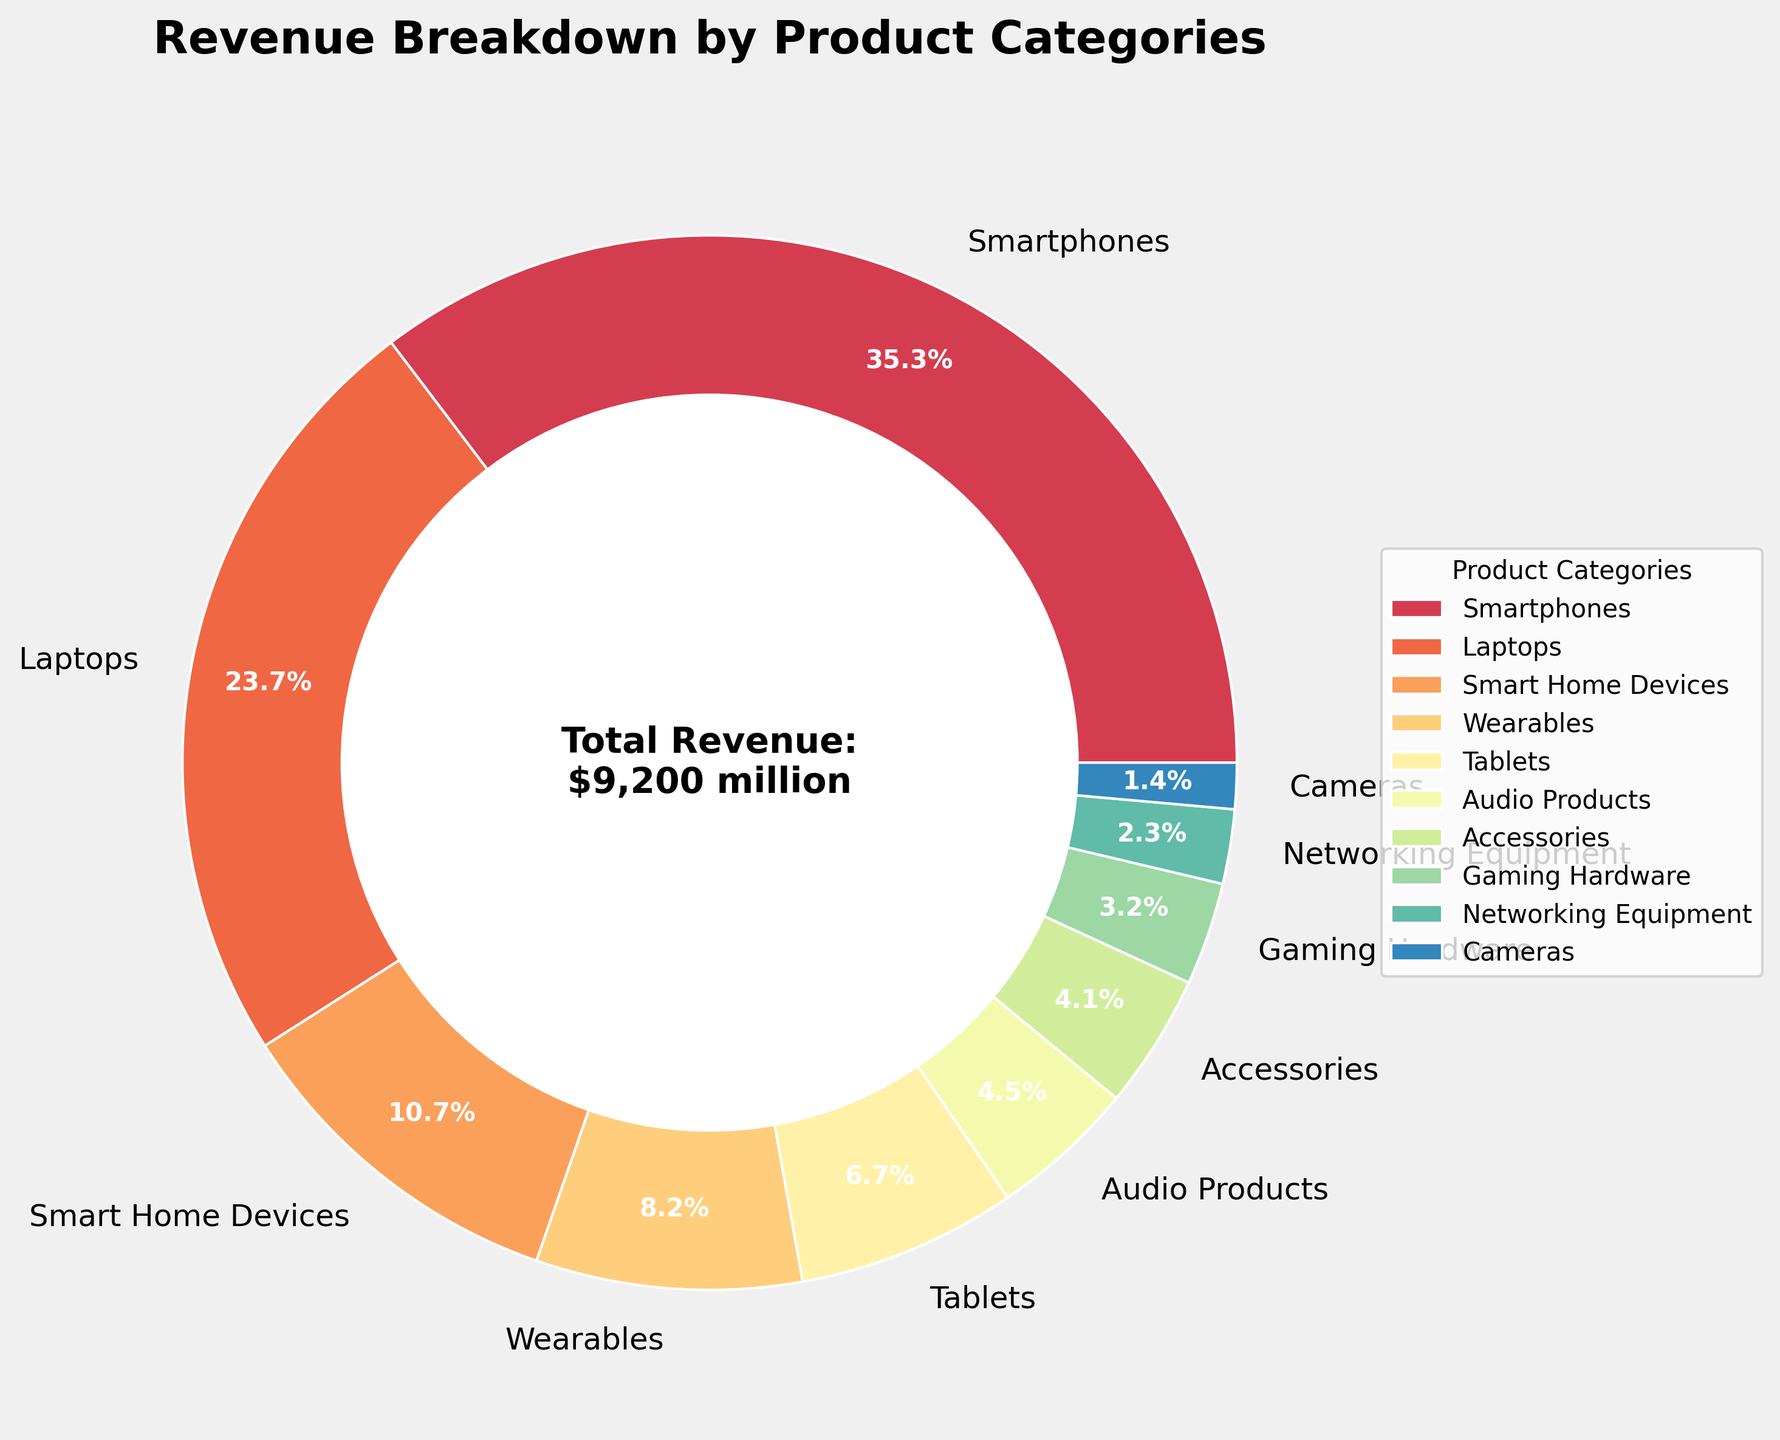What's the product category with the highest revenue? The pie chart shows individual segments for each product category. By looking at the largest segment, it corresponds to the "Smartphones" category, which also has the highest percentage.
Answer: Smartphones What's the combined revenue share of Wearables, Tablets, and Audio Products? First, find the individual percentages for "Wearables", "Tablets", and "Audio Products". Wearables: 7.8%, Tablets: 6.4%, Audio Products: 4.1%. Adding them together: 7.8% + 6.4% + 4.1% = 18.3%.
Answer: 18.3% Which category contributes more to the revenue: Laptops or Smart Home Devices? The pie chart shows different segments with their sizes representing percentages. The segment for Laptops is much larger than the one for Smart Home Devices: Laptops have approximately 21.8% while Smart Home Devices have about 9.8%.
Answer: Laptops What is the revenue difference between the highest and lowest revenue generating categories? From the pie chart, the highest revenue is from Smartphones (32.5%) and the lowest revenue is from Cameras (1.3%). The difference in percentage is 32.5% - 1.3% = 31.2%.
Answer: 31.2% How many categories contribute less than 5% to the total revenue each? Visually inspect the pie chart to identify the segments representing categories with less than 5%. These are Audio Products, Accessories, Gaming Hardware, Networking Equipment, and Cameras. There are 5 such categories.
Answer: 5 What is the total revenue for the categories contributing more than 25% combined? The categories such as Smartphones (32.5%) contribute more than 25% by itself. Therefore, the total revenue is just the revenue of Smartphones. The total revenue is $3,250 million.
Answer: $3,250 million Compare the revenue share of Tablets and Networking Equipment. Which one is higher and by how much? Tablets have a share of 6.4%, whereas Networking Equipment has a share of 2.1%. The difference is 6.4% - 2.1% = 4.3%, with Tablets having the higher share.
Answer: Tablets by 4.3% Which product category’s revenue segment is colored at the beginning of the spectrum (typically red in a spectral colormap)? The pie chart assigns colors from the Spectral colormap. Typically, the beginning segment (red) in this colormap is assigned to the category with the highest revenue. In this case, it was assigned to Smartphones.
Answer: Smartphones 